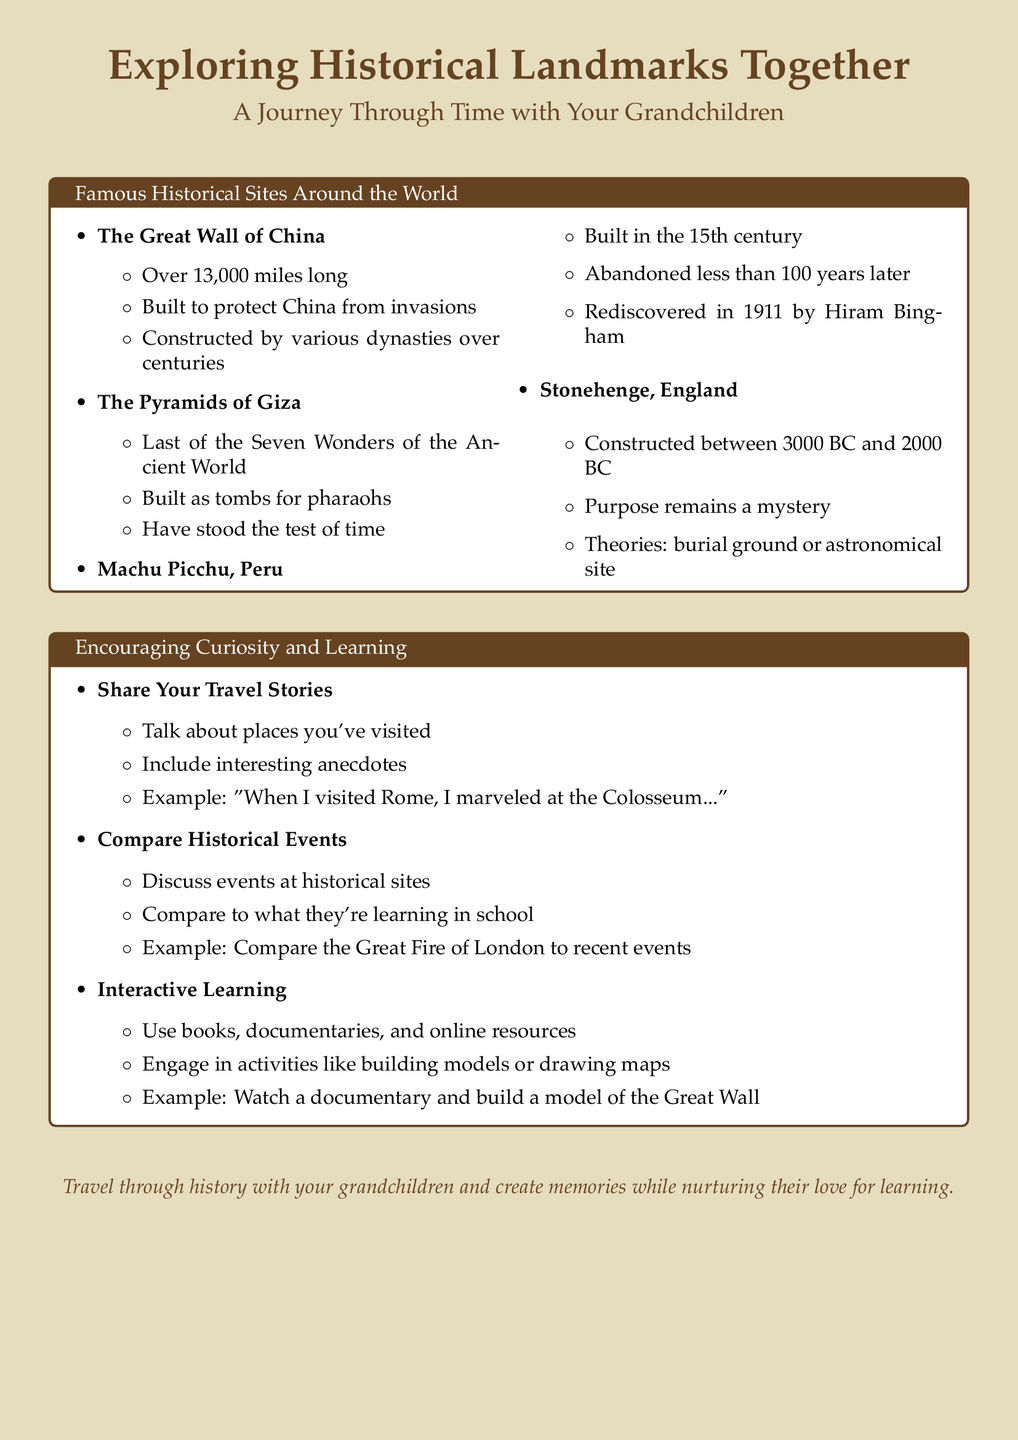What is the length of the Great Wall of China? The document states that the Great Wall of China is over 13,000 miles long.
Answer: over 13,000 miles What is one purpose of the Pyramids of Giza? The Pyramids of Giza were built as tombs for pharaohs.
Answer: tombs for pharaohs What year was Machu Picchu rediscovered? The document mentions that Machu Picchu was rediscovered in 1911.
Answer: 1911 What remains a mystery regarding Stonehenge? The document indicates that the purpose of Stonehenge remains a mystery.
Answer: purpose remains a mystery What kind of activities can grandparents engage in with their grandchildren? The document lists activities like building models or drawing maps as engaging learning activities.
Answer: building models or drawing maps How can grandparents compare historical events? The document suggests discussing events at historical sites and comparing them to what grandchildren are learning in school.
Answer: discuss events at historical sites What's an example of a travel story grandparents can share? The document provides an example of visiting Rome and marveling at the Colosseum.
Answer: marveling at the Colosseum What should be included in travel stories shared by grandparents? The document mentions including interesting anecdotes in travel stories.
Answer: interesting anecdotes What type of resources can be used for interactive learning? The document suggests using books, documentaries, and online resources for interactive learning.
Answer: books, documentaries, and online resources 